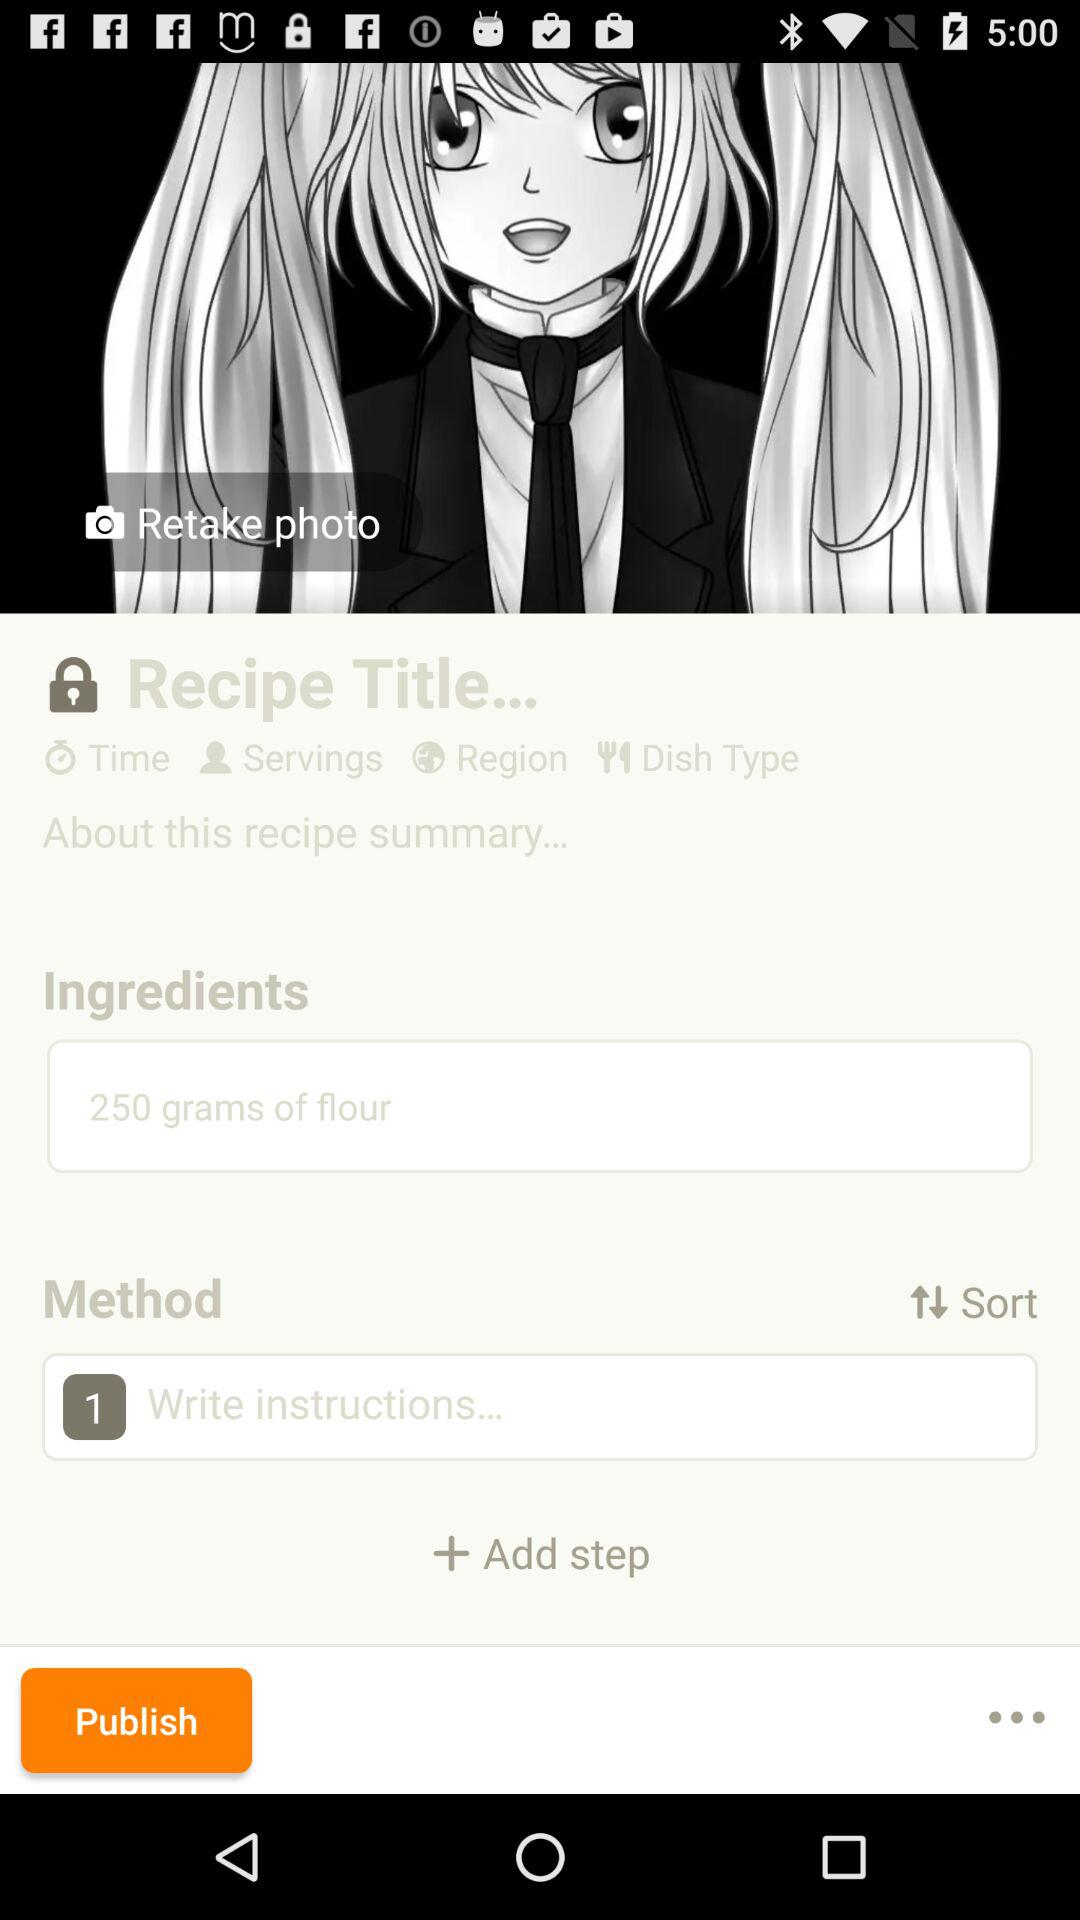How many steps are there in this recipe?
Answer the question using a single word or phrase. 1 